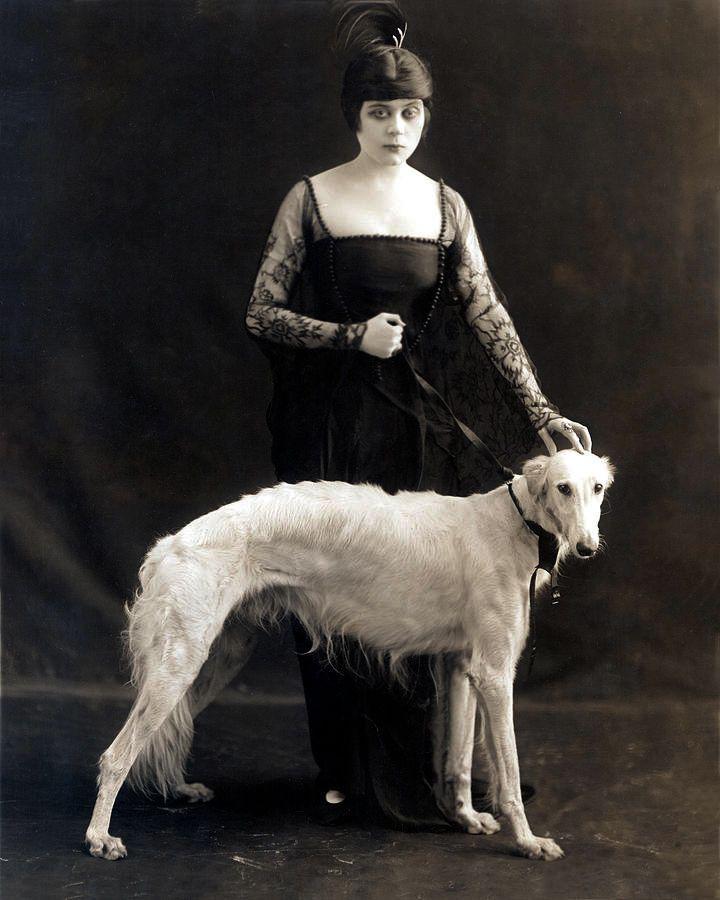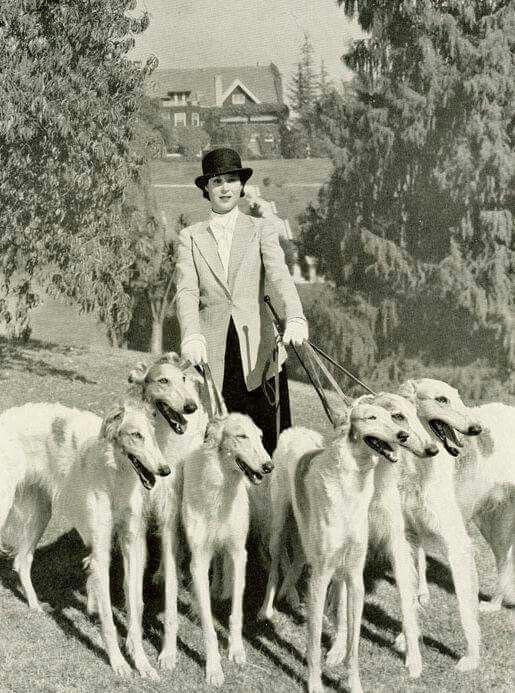The first image is the image on the left, the second image is the image on the right. Considering the images on both sides, is "A woman is standing with a single dog." valid? Answer yes or no. Yes. The first image is the image on the left, the second image is the image on the right. Analyze the images presented: Is the assertion "An image shows a lady in a dark gown standing behind one hound." valid? Answer yes or no. Yes. 